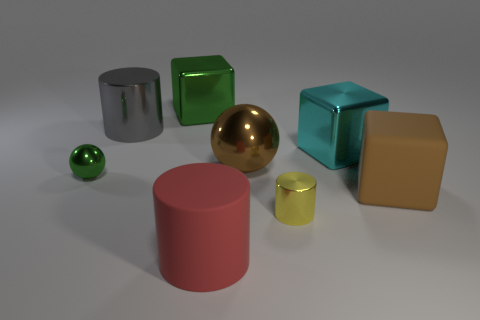What shape is the tiny green object?
Provide a short and direct response. Sphere. Is the number of big blocks that are to the right of the yellow metal cylinder greater than the number of large brown blocks?
Offer a terse response. Yes. What is the shape of the green object that is in front of the big metal cylinder?
Your response must be concise. Sphere. What number of other objects are there of the same shape as the large red rubber object?
Ensure brevity in your answer.  2. Does the sphere that is left of the green shiny cube have the same material as the yellow object?
Ensure brevity in your answer.  Yes. Is the number of big metal blocks behind the tiny yellow metal object the same as the number of cylinders that are behind the big rubber cylinder?
Make the answer very short. Yes. There is a metal cylinder in front of the cyan metal block; what is its size?
Your answer should be very brief. Small. Are there any tiny balls made of the same material as the big brown cube?
Your answer should be compact. No. Does the sphere on the right side of the red object have the same color as the big rubber cube?
Keep it short and to the point. Yes. Are there the same number of large rubber cylinders in front of the large gray shiny object and brown balls?
Offer a very short reply. Yes. 